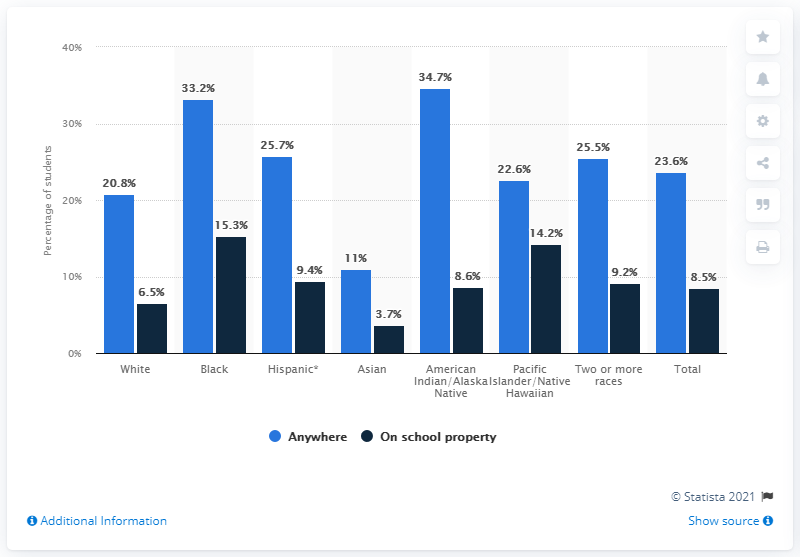Mention a couple of crucial points in this snapshot. According to a report from 2017, 6.5% of white students reported being involved in a physical fight on school property. 